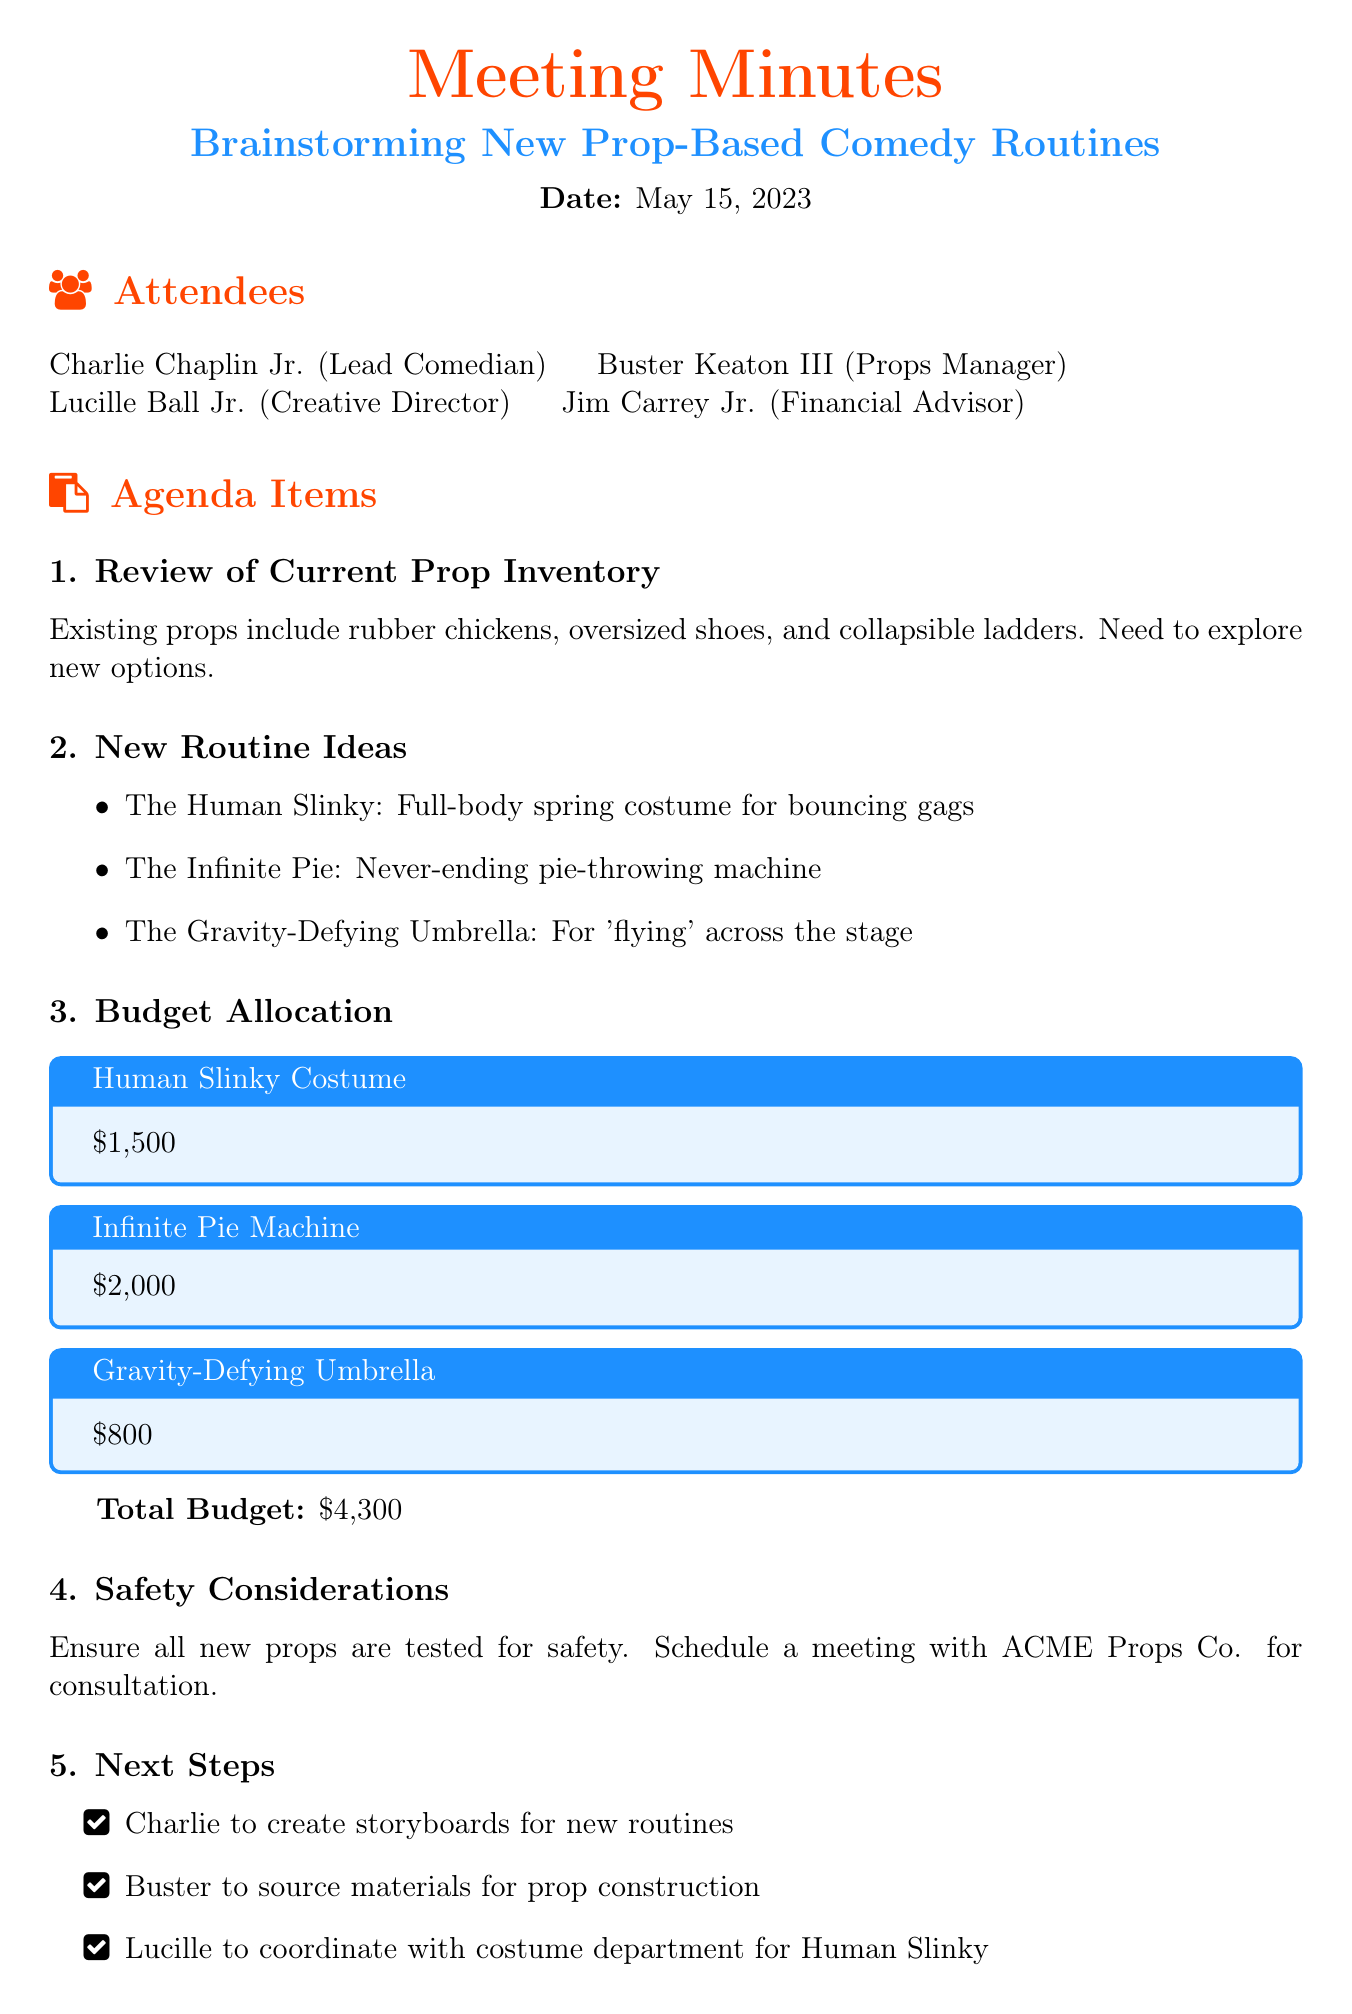What is the date of the meeting? The date of the meeting is explicitly stated in the document.
Answer: May 15, 2023 Who is the Financial Advisor? The role of Financial Advisor is assigned to one of the attendees in the document.
Answer: Jim Carrey Jr What is the budget for the Human Slinky Costume? The document lists budget allocations for each prop, including the Human Slinky Costume.
Answer: $1,500 What is the total budget for all props? The total budget is provided at the end of the budget allocation section.
Answer: $4,300 How many new routine ideas are presented? The number of new routine ideas is clearly indicated in the list.
Answer: Three What safety step needs to be taken before using new props? The document emphasizes a specific precaution involving safety measures for new props.
Answer: Tested for safety Who is responsible for creating storyboards for new routines? The document assigns responsibilities to attendees, including who will create storyboards.
Answer: Charlie What machine is mentioned as "never-ending"? The name of the machine described as never-ending is listed in the new routine ideas section.
Answer: Infinite Pie Machine 